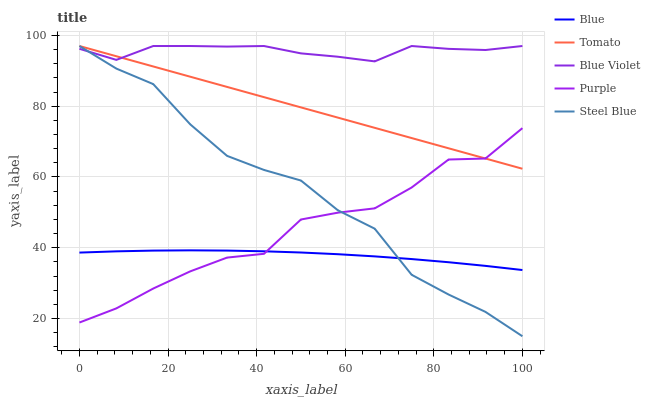Does Blue have the minimum area under the curve?
Answer yes or no. Yes. Does Blue Violet have the maximum area under the curve?
Answer yes or no. Yes. Does Tomato have the minimum area under the curve?
Answer yes or no. No. Does Tomato have the maximum area under the curve?
Answer yes or no. No. Is Tomato the smoothest?
Answer yes or no. Yes. Is Purple the roughest?
Answer yes or no. Yes. Is Purple the smoothest?
Answer yes or no. No. Is Tomato the roughest?
Answer yes or no. No. Does Tomato have the lowest value?
Answer yes or no. No. Does Blue Violet have the highest value?
Answer yes or no. Yes. Does Purple have the highest value?
Answer yes or no. No. Is Blue less than Tomato?
Answer yes or no. Yes. Is Blue Violet greater than Blue?
Answer yes or no. Yes. Does Blue intersect Tomato?
Answer yes or no. No. 